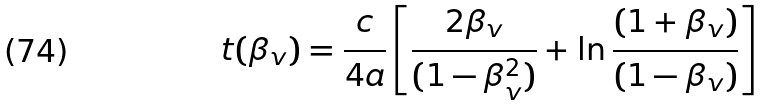Convert formula to latex. <formula><loc_0><loc_0><loc_500><loc_500>t ( \beta _ { v } ) = \frac { c } { 4 a } \left [ \frac { 2 \beta _ { v } } { ( 1 - \beta _ { v } ^ { 2 } ) } + \ln \frac { ( 1 + \beta _ { v } ) } { ( 1 - \beta _ { v } ) } \right ]</formula> 